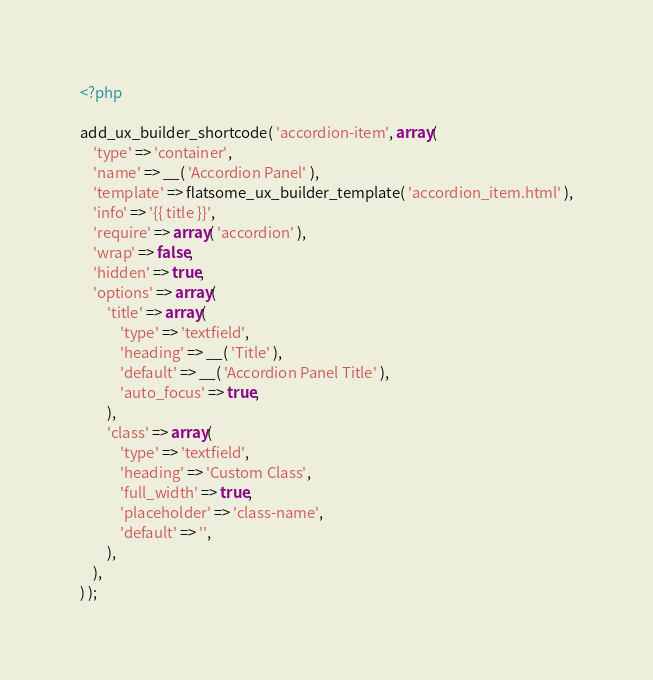<code> <loc_0><loc_0><loc_500><loc_500><_PHP_><?php

add_ux_builder_shortcode( 'accordion-item', array(
    'type' => 'container',
    'name' => __( 'Accordion Panel' ),
    'template' => flatsome_ux_builder_template( 'accordion_item.html' ),
    'info' => '{{ title }}',
    'require' => array( 'accordion' ),
    'wrap' => false,
    'hidden' => true,
    'options' => array(
        'title' => array(
            'type' => 'textfield',
            'heading' => __( 'Title' ),
            'default' => __( 'Accordion Panel Title' ),
            'auto_focus' => true,
        ),
        'class' => array(
            'type' => 'textfield',
            'heading' => 'Custom Class',
            'full_width' => true,
            'placeholder' => 'class-name',
            'default' => '',
        ),
    ),
) );
</code> 